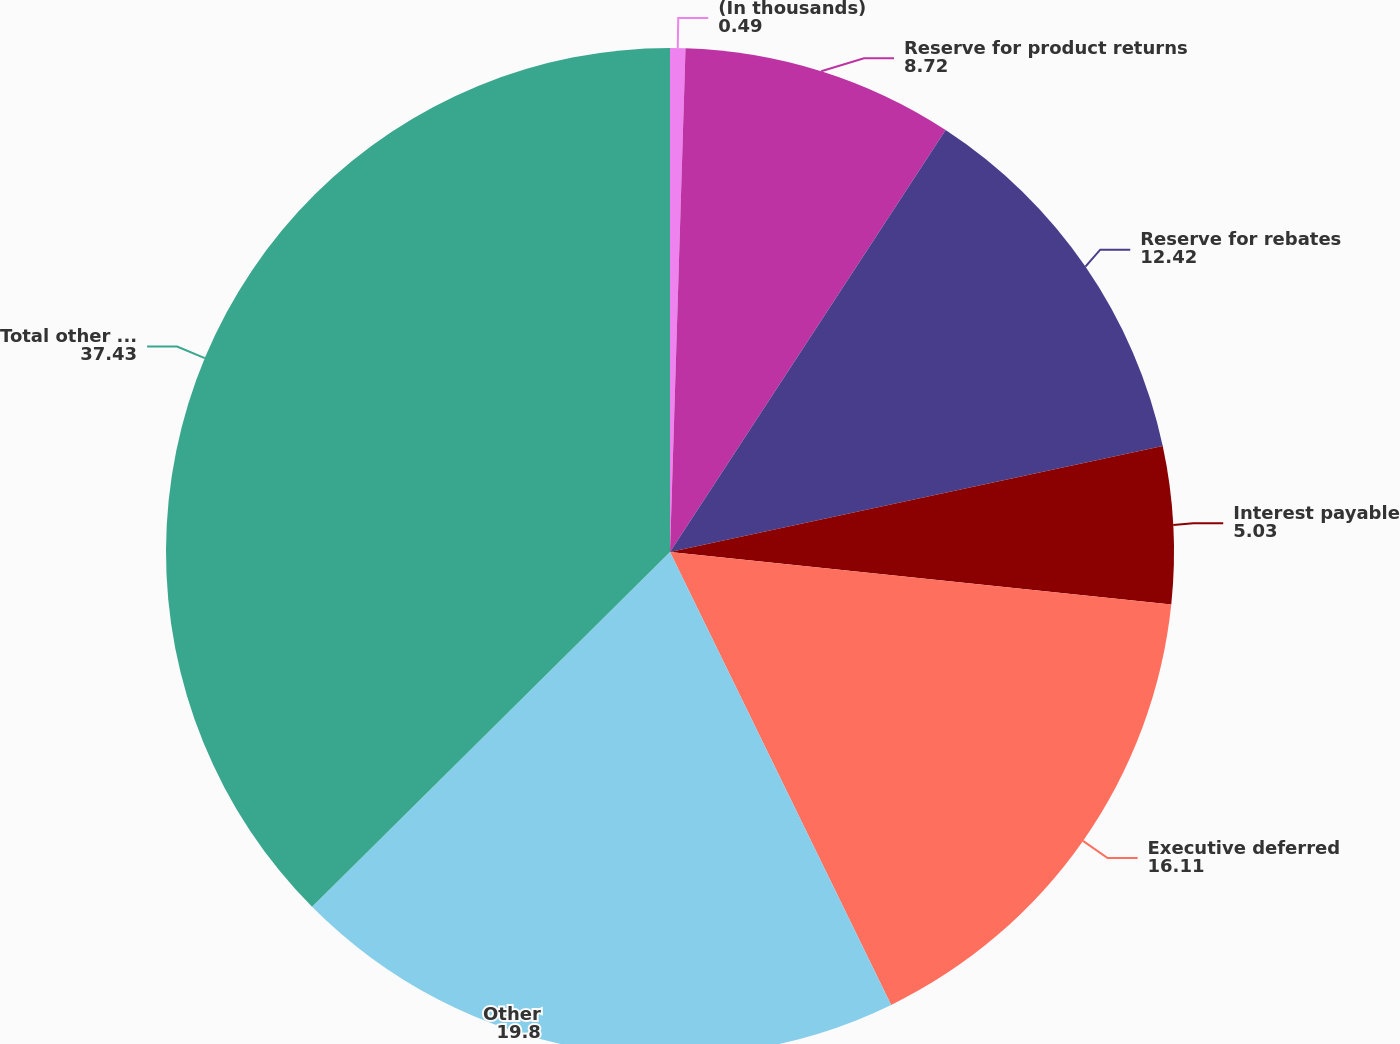Convert chart. <chart><loc_0><loc_0><loc_500><loc_500><pie_chart><fcel>(In thousands)<fcel>Reserve for product returns<fcel>Reserve for rebates<fcel>Interest payable<fcel>Executive deferred<fcel>Other<fcel>Total other current<nl><fcel>0.49%<fcel>8.72%<fcel>12.42%<fcel>5.03%<fcel>16.11%<fcel>19.8%<fcel>37.43%<nl></chart> 